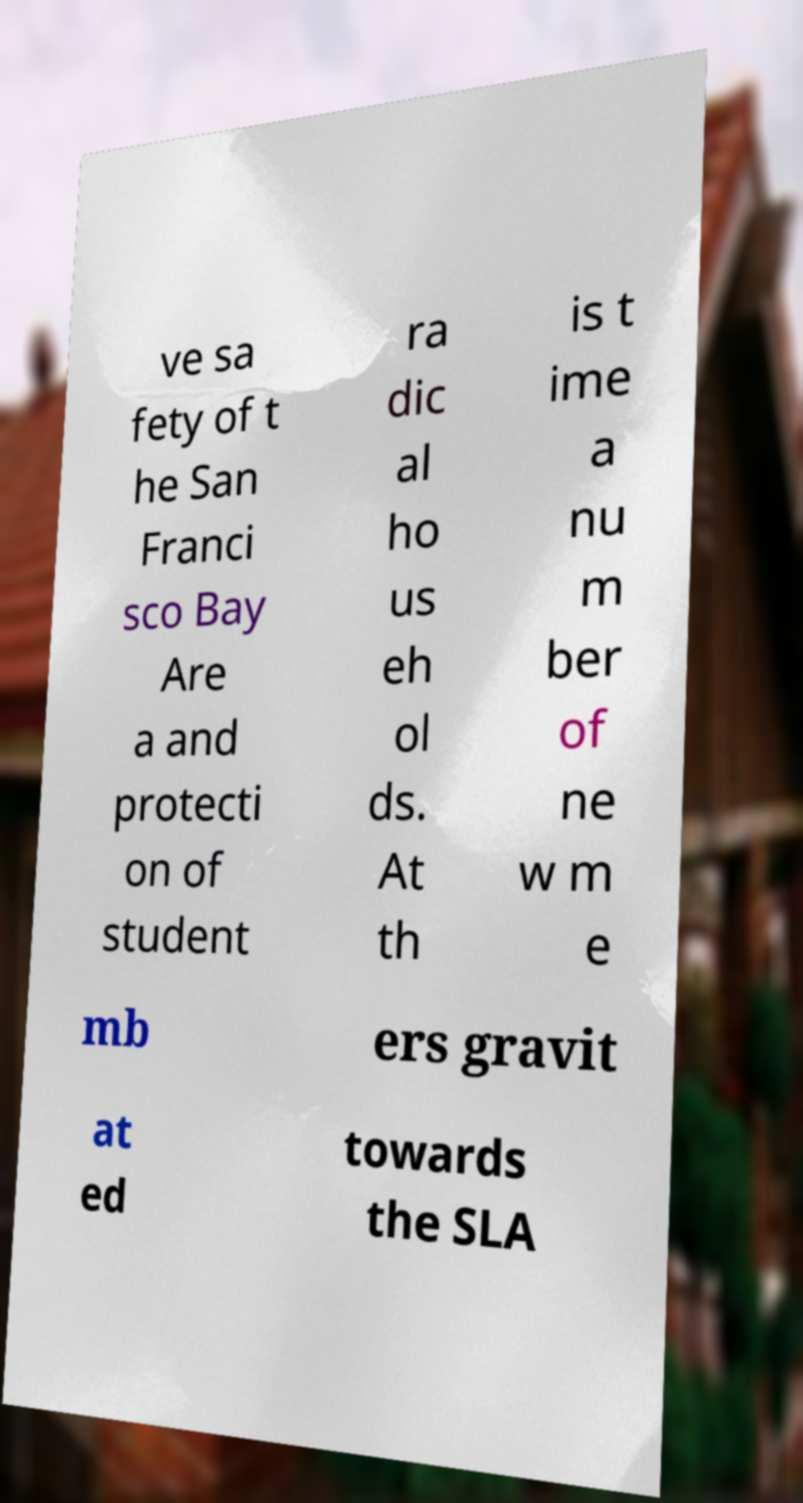Could you assist in decoding the text presented in this image and type it out clearly? ve sa fety of t he San Franci sco Bay Are a and protecti on of student ra dic al ho us eh ol ds. At th is t ime a nu m ber of ne w m e mb ers gravit at ed towards the SLA 